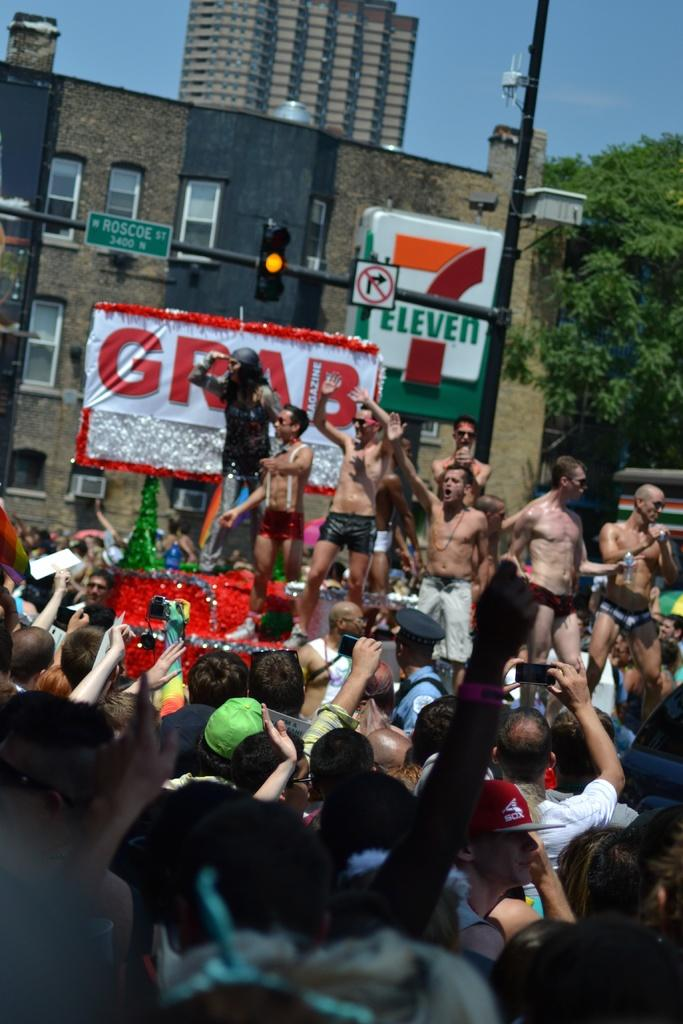How many people are present in the image? There are many people in the image. What structures can be seen in the image? There are buildings in the image. What type of vegetation is present in the image? There are trees in the image. What part of the natural environment is visible in the image? The sky is visible in the image. What type of teeth can be seen in the image? There are no teeth visible in the image. Is the street visible in the image? The provided facts do not mention a street, so it cannot be determined if it is visible in the image. 